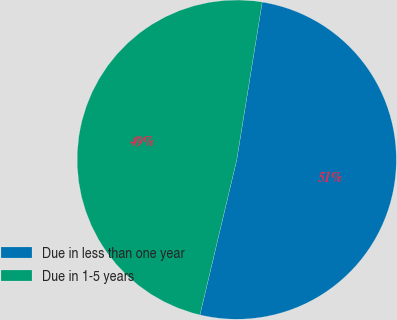<chart> <loc_0><loc_0><loc_500><loc_500><pie_chart><fcel>Due in less than one year<fcel>Due in 1-5 years<nl><fcel>51.16%<fcel>48.84%<nl></chart> 